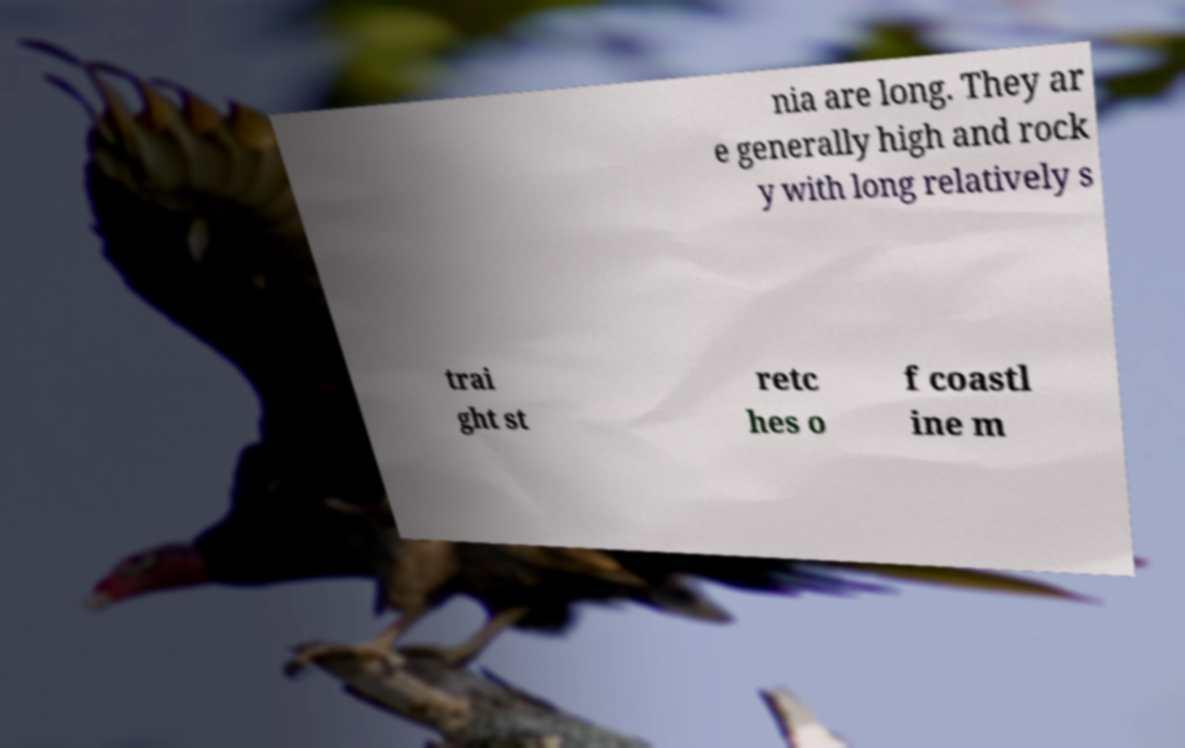Please read and relay the text visible in this image. What does it say? nia are long. They ar e generally high and rock y with long relatively s trai ght st retc hes o f coastl ine m 